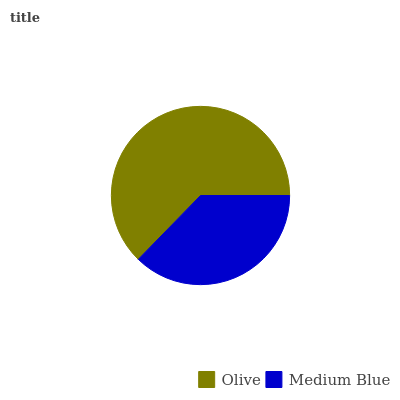Is Medium Blue the minimum?
Answer yes or no. Yes. Is Olive the maximum?
Answer yes or no. Yes. Is Medium Blue the maximum?
Answer yes or no. No. Is Olive greater than Medium Blue?
Answer yes or no. Yes. Is Medium Blue less than Olive?
Answer yes or no. Yes. Is Medium Blue greater than Olive?
Answer yes or no. No. Is Olive less than Medium Blue?
Answer yes or no. No. Is Olive the high median?
Answer yes or no. Yes. Is Medium Blue the low median?
Answer yes or no. Yes. Is Medium Blue the high median?
Answer yes or no. No. Is Olive the low median?
Answer yes or no. No. 